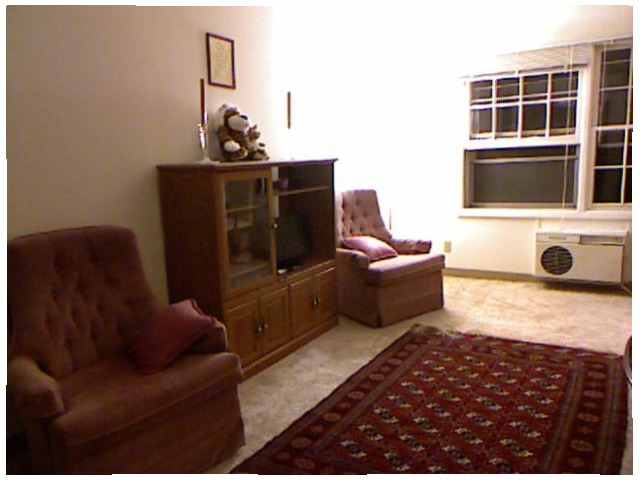<image>
Can you confirm if the bear is above the cabinet? No. The bear is not positioned above the cabinet. The vertical arrangement shows a different relationship. Is there a soft toy under the photo frame? Yes. The soft toy is positioned underneath the photo frame, with the photo frame above it in the vertical space. 